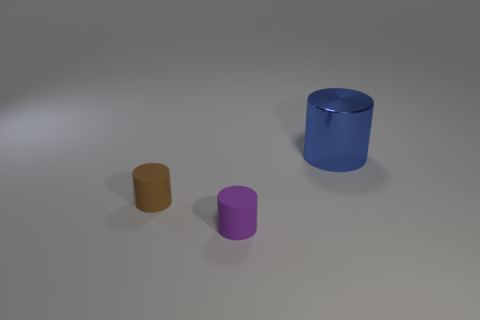There is a matte object that is in front of the cylinder left of the matte cylinder that is to the right of the brown matte object; how big is it?
Your response must be concise. Small. There is another purple rubber object that is the same shape as the large object; what is its size?
Your answer should be very brief. Small. There is a tiny object left of the cylinder in front of the tiny brown matte cylinder; what shape is it?
Give a very brief answer. Cylinder. Are there any metal cylinders that have the same size as the metal thing?
Your response must be concise. No. The brown matte thing has what shape?
Provide a short and direct response. Cylinder. Is the number of small brown matte things in front of the shiny cylinder greater than the number of blue cylinders that are in front of the purple rubber thing?
Keep it short and to the point. Yes. There is another object that is the same size as the brown rubber thing; what is its shape?
Make the answer very short. Cylinder. Are there any gray matte objects that have the same shape as the large blue metallic object?
Offer a very short reply. No. Is the material of the cylinder that is to the right of the purple cylinder the same as the cylinder in front of the brown rubber object?
Keep it short and to the point. No. What number of blue objects are the same material as the purple object?
Make the answer very short. 0. 